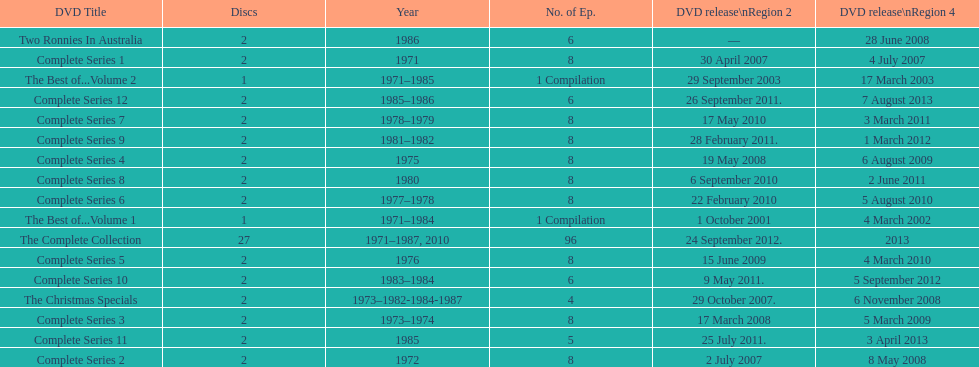What comes immediately after complete series 11? Complete Series 12. 